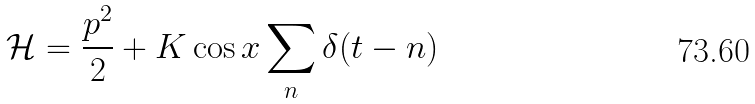Convert formula to latex. <formula><loc_0><loc_0><loc_500><loc_500>\mathcal { H } = \frac { p ^ { 2 } } { 2 } + K \cos x \sum _ { n } \delta ( t - n )</formula> 